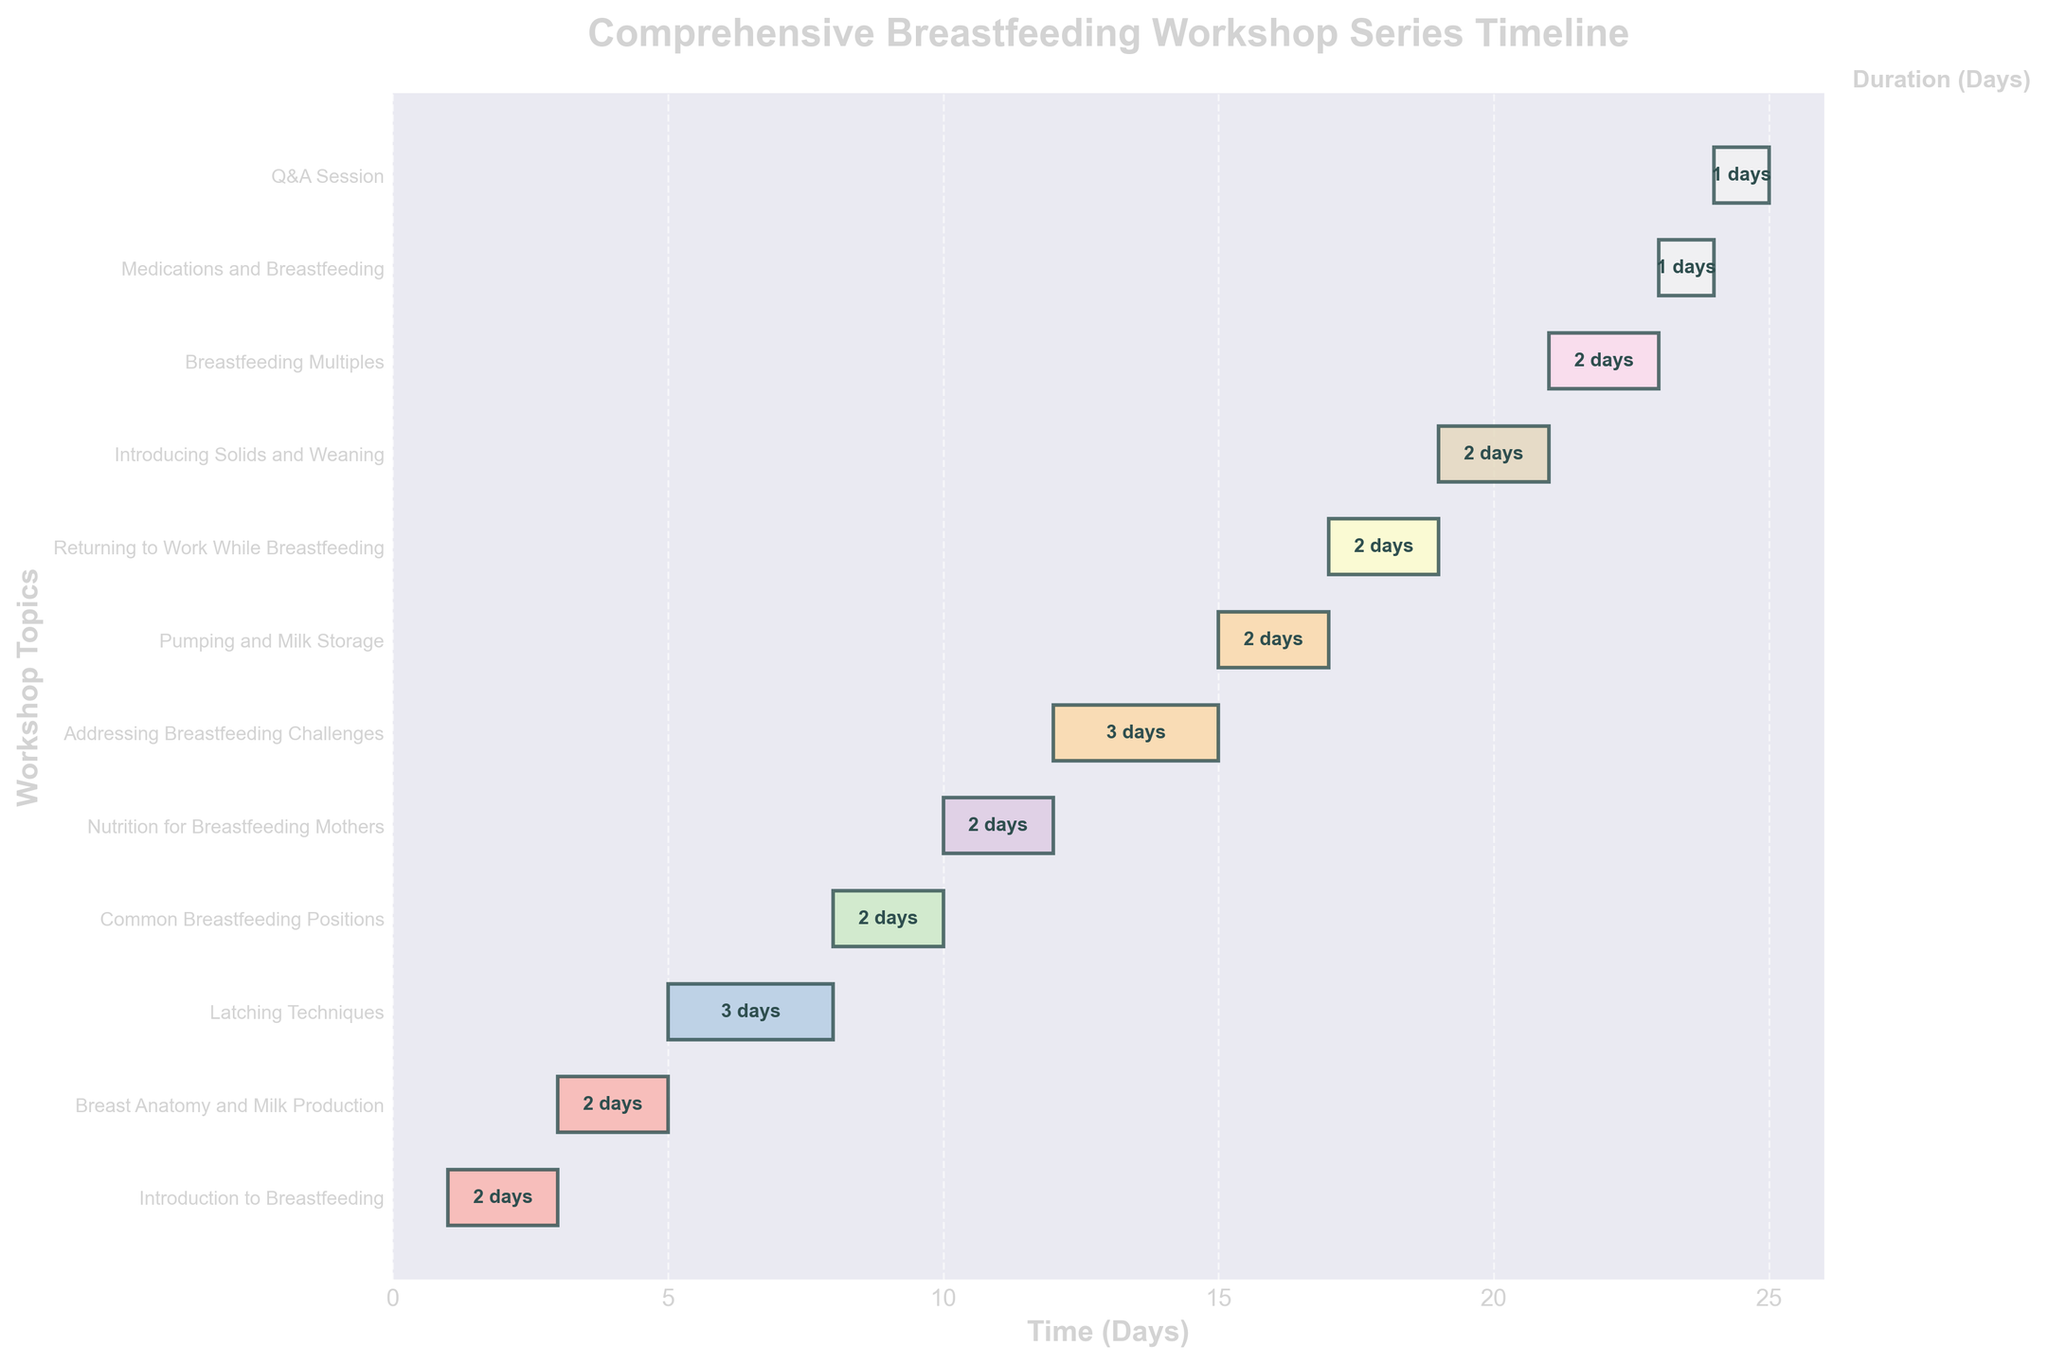What's the duration of the "Latching Techniques" topic? Locate the "Latching Techniques" task on the y-axis. It has a bar extending from day 5 to day 8, indicating a duration of 3 days.
Answer: 3 days What is the color used for the "Introduction to Breastfeeding" bar in the Gantt Chart? Identify the bar representing "Introduction to Breastfeeding" at the top of the Gantt chart, which is colored using a pastel shade from a colormap. The exact color isn't provided, but it is a pastel color from the gradient used in the chart.
Answer: Pastel color Which topic starts immediately after the "Common Breastfeeding Positions" topic? Look at the positioning of the bars. The "Common Breastfeeding Positions" bar ends on day 10. The next bar, starting at day 10, is "Nutrition for Breastfeeding Mothers".
Answer: Nutrition for Breastfeeding Mothers What is the total duration of the breastfeeding workshop series? The chart ends with the "Q&A Session", which starts on day 24 and lasts 1 day, therefore concluding on day 25. So, the workshop series spans from day 1 to day 25.
Answer: 25 days Which topic has the shortest duration? Identify the shortest bar in the chart, which is "Medications and Breastfeeding" lasting 1 day.
Answer: Medications and Breastfeeding How many topics last exactly 2 days? Count the number of bars with lengths corresponding to 2 days. There are seven topics: "Introduction to Breastfeeding", "Breast Anatomy and Milk Production", "Common Breastfeeding Positions", "Nutrition for Breastfeeding Mothers", "Pumping and Milk Storage", "Returning to Work While Breastfeeding", "Introducing Solids and Weaning", and "Breastfeeding Multiples".
Answer: 8 topics What is the combined duration of "Latching Techniques" and "Addressing Breastfeeding Challenges"? "Latching Techniques" lasts 3 days, and "Addressing Breastfeeding Challenges" lasts 3 days. Adding them together gives a total duration of 6 days.
Answer: 6 days During which days does the "Pumping and Milk Storage" topic occur? Look for "Pumping and Milk Storage" on the y-axis, which starts on day 15 and ends on day 17.
Answer: Days 15 to 17 Is there any day that has no topic scheduled? Check the gaps between bars on the chart. Not a single day within the range appears to be empty from day 1 to day 25 given the continuous representation of tasks without gaps in the timeline.
Answer: No 